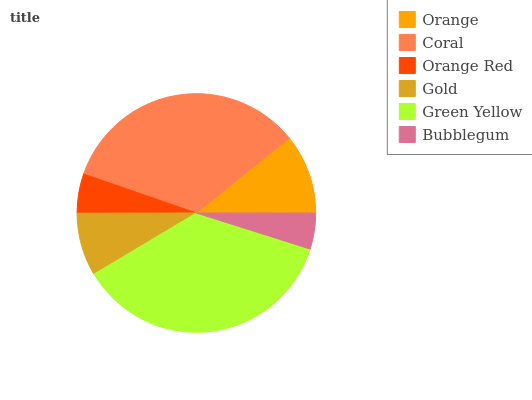Is Bubblegum the minimum?
Answer yes or no. Yes. Is Green Yellow the maximum?
Answer yes or no. Yes. Is Coral the minimum?
Answer yes or no. No. Is Coral the maximum?
Answer yes or no. No. Is Coral greater than Orange?
Answer yes or no. Yes. Is Orange less than Coral?
Answer yes or no. Yes. Is Orange greater than Coral?
Answer yes or no. No. Is Coral less than Orange?
Answer yes or no. No. Is Orange the high median?
Answer yes or no. Yes. Is Gold the low median?
Answer yes or no. Yes. Is Orange Red the high median?
Answer yes or no. No. Is Orange the low median?
Answer yes or no. No. 